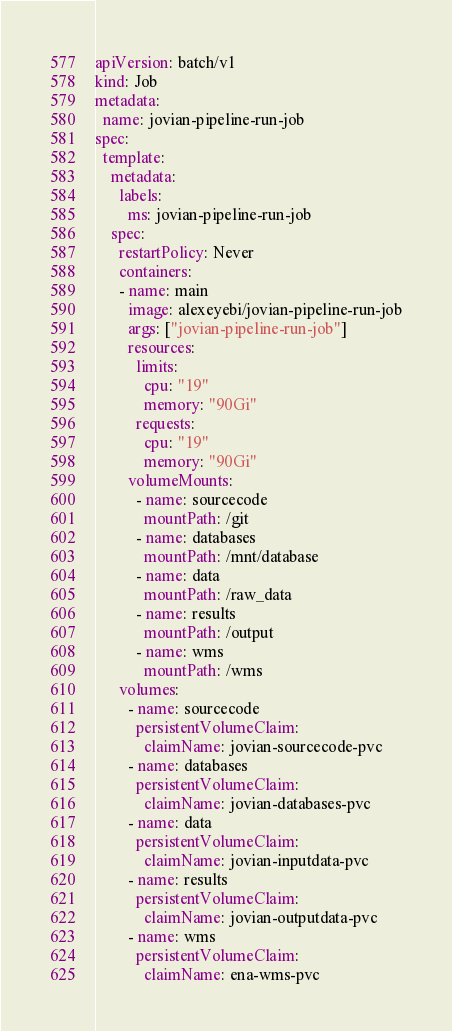Convert code to text. <code><loc_0><loc_0><loc_500><loc_500><_YAML_>apiVersion: batch/v1
kind: Job
metadata:
  name: jovian-pipeline-run-job
spec:
  template:
    metadata:
      labels:
        ms: jovian-pipeline-run-job
    spec:
      restartPolicy: Never
      containers:
      - name: main
        image: alexeyebi/jovian-pipeline-run-job
        args: ["jovian-pipeline-run-job"]
        resources:
          limits:
            cpu: "19"
            memory: "90Gi"
          requests:
            cpu: "19"
            memory: "90Gi"
        volumeMounts:
          - name: sourcecode
            mountPath: /git
          - name: databases
            mountPath: /mnt/database
          - name: data
            mountPath: /raw_data
          - name: results
            mountPath: /output
          - name: wms
            mountPath: /wms
      volumes:
        - name: sourcecode
          persistentVolumeClaim:
            claimName: jovian-sourcecode-pvc
        - name: databases
          persistentVolumeClaim:
            claimName: jovian-databases-pvc
        - name: data
          persistentVolumeClaim:
            claimName: jovian-inputdata-pvc
        - name: results
          persistentVolumeClaim:
            claimName: jovian-outputdata-pvc
        - name: wms
          persistentVolumeClaim:
            claimName: ena-wms-pvc
</code> 